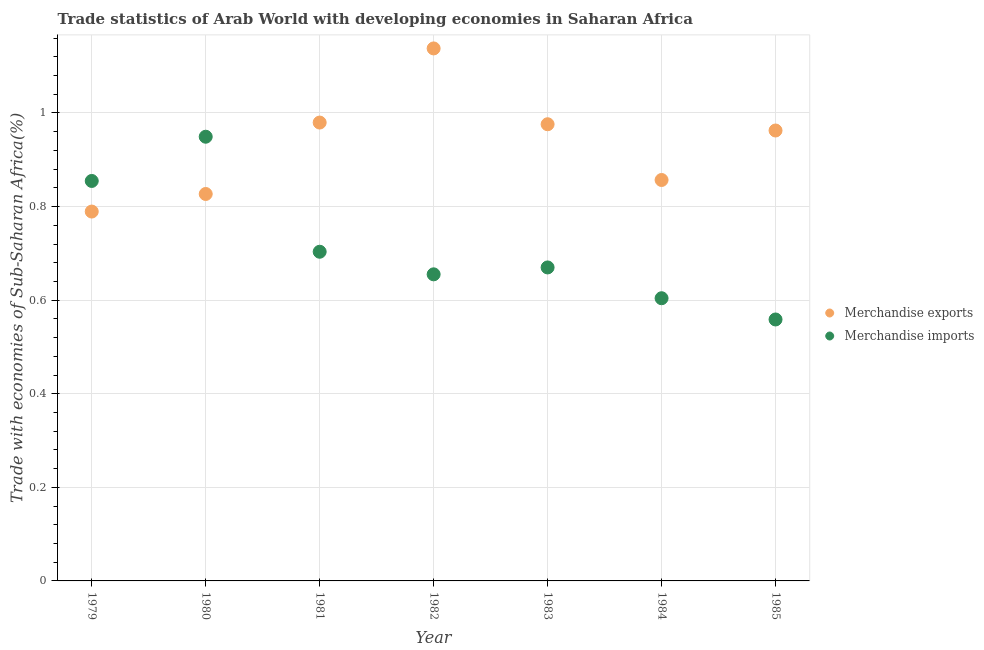How many different coloured dotlines are there?
Provide a succinct answer. 2. Is the number of dotlines equal to the number of legend labels?
Your response must be concise. Yes. What is the merchandise exports in 1981?
Keep it short and to the point. 0.98. Across all years, what is the maximum merchandise exports?
Your answer should be compact. 1.14. Across all years, what is the minimum merchandise exports?
Offer a very short reply. 0.79. In which year was the merchandise exports minimum?
Ensure brevity in your answer.  1979. What is the total merchandise imports in the graph?
Make the answer very short. 5. What is the difference between the merchandise imports in 1980 and that in 1984?
Offer a terse response. 0.35. What is the difference between the merchandise exports in 1985 and the merchandise imports in 1980?
Your answer should be compact. 0.01. What is the average merchandise imports per year?
Your answer should be very brief. 0.71. In the year 1984, what is the difference between the merchandise imports and merchandise exports?
Give a very brief answer. -0.25. In how many years, is the merchandise imports greater than 0.36 %?
Your response must be concise. 7. What is the ratio of the merchandise exports in 1982 to that in 1985?
Keep it short and to the point. 1.18. Is the merchandise imports in 1984 less than that in 1985?
Give a very brief answer. No. What is the difference between the highest and the second highest merchandise imports?
Your response must be concise. 0.09. What is the difference between the highest and the lowest merchandise exports?
Make the answer very short. 0.35. Is the merchandise exports strictly greater than the merchandise imports over the years?
Provide a short and direct response. No. How many years are there in the graph?
Give a very brief answer. 7. Does the graph contain any zero values?
Provide a short and direct response. No. Does the graph contain grids?
Your response must be concise. Yes. Where does the legend appear in the graph?
Keep it short and to the point. Center right. How many legend labels are there?
Provide a short and direct response. 2. What is the title of the graph?
Provide a succinct answer. Trade statistics of Arab World with developing economies in Saharan Africa. What is the label or title of the Y-axis?
Your response must be concise. Trade with economies of Sub-Saharan Africa(%). What is the Trade with economies of Sub-Saharan Africa(%) of Merchandise exports in 1979?
Your response must be concise. 0.79. What is the Trade with economies of Sub-Saharan Africa(%) of Merchandise imports in 1979?
Your response must be concise. 0.85. What is the Trade with economies of Sub-Saharan Africa(%) of Merchandise exports in 1980?
Offer a terse response. 0.83. What is the Trade with economies of Sub-Saharan Africa(%) of Merchandise imports in 1980?
Provide a short and direct response. 0.95. What is the Trade with economies of Sub-Saharan Africa(%) of Merchandise exports in 1981?
Your answer should be compact. 0.98. What is the Trade with economies of Sub-Saharan Africa(%) in Merchandise imports in 1981?
Keep it short and to the point. 0.7. What is the Trade with economies of Sub-Saharan Africa(%) of Merchandise exports in 1982?
Keep it short and to the point. 1.14. What is the Trade with economies of Sub-Saharan Africa(%) of Merchandise imports in 1982?
Provide a short and direct response. 0.66. What is the Trade with economies of Sub-Saharan Africa(%) in Merchandise exports in 1983?
Keep it short and to the point. 0.98. What is the Trade with economies of Sub-Saharan Africa(%) of Merchandise imports in 1983?
Your answer should be very brief. 0.67. What is the Trade with economies of Sub-Saharan Africa(%) in Merchandise exports in 1984?
Offer a very short reply. 0.86. What is the Trade with economies of Sub-Saharan Africa(%) in Merchandise imports in 1984?
Offer a terse response. 0.6. What is the Trade with economies of Sub-Saharan Africa(%) of Merchandise exports in 1985?
Provide a succinct answer. 0.96. What is the Trade with economies of Sub-Saharan Africa(%) of Merchandise imports in 1985?
Provide a succinct answer. 0.56. Across all years, what is the maximum Trade with economies of Sub-Saharan Africa(%) of Merchandise exports?
Your response must be concise. 1.14. Across all years, what is the maximum Trade with economies of Sub-Saharan Africa(%) of Merchandise imports?
Provide a short and direct response. 0.95. Across all years, what is the minimum Trade with economies of Sub-Saharan Africa(%) of Merchandise exports?
Your answer should be compact. 0.79. Across all years, what is the minimum Trade with economies of Sub-Saharan Africa(%) of Merchandise imports?
Give a very brief answer. 0.56. What is the total Trade with economies of Sub-Saharan Africa(%) in Merchandise exports in the graph?
Ensure brevity in your answer.  6.53. What is the total Trade with economies of Sub-Saharan Africa(%) in Merchandise imports in the graph?
Make the answer very short. 5. What is the difference between the Trade with economies of Sub-Saharan Africa(%) of Merchandise exports in 1979 and that in 1980?
Make the answer very short. -0.04. What is the difference between the Trade with economies of Sub-Saharan Africa(%) in Merchandise imports in 1979 and that in 1980?
Offer a very short reply. -0.09. What is the difference between the Trade with economies of Sub-Saharan Africa(%) of Merchandise exports in 1979 and that in 1981?
Offer a very short reply. -0.19. What is the difference between the Trade with economies of Sub-Saharan Africa(%) in Merchandise imports in 1979 and that in 1981?
Ensure brevity in your answer.  0.15. What is the difference between the Trade with economies of Sub-Saharan Africa(%) of Merchandise exports in 1979 and that in 1982?
Your response must be concise. -0.35. What is the difference between the Trade with economies of Sub-Saharan Africa(%) in Merchandise imports in 1979 and that in 1982?
Provide a short and direct response. 0.2. What is the difference between the Trade with economies of Sub-Saharan Africa(%) of Merchandise exports in 1979 and that in 1983?
Make the answer very short. -0.19. What is the difference between the Trade with economies of Sub-Saharan Africa(%) in Merchandise imports in 1979 and that in 1983?
Ensure brevity in your answer.  0.18. What is the difference between the Trade with economies of Sub-Saharan Africa(%) in Merchandise exports in 1979 and that in 1984?
Offer a very short reply. -0.07. What is the difference between the Trade with economies of Sub-Saharan Africa(%) in Merchandise imports in 1979 and that in 1984?
Offer a very short reply. 0.25. What is the difference between the Trade with economies of Sub-Saharan Africa(%) of Merchandise exports in 1979 and that in 1985?
Offer a terse response. -0.17. What is the difference between the Trade with economies of Sub-Saharan Africa(%) in Merchandise imports in 1979 and that in 1985?
Your response must be concise. 0.3. What is the difference between the Trade with economies of Sub-Saharan Africa(%) in Merchandise exports in 1980 and that in 1981?
Give a very brief answer. -0.15. What is the difference between the Trade with economies of Sub-Saharan Africa(%) in Merchandise imports in 1980 and that in 1981?
Offer a very short reply. 0.25. What is the difference between the Trade with economies of Sub-Saharan Africa(%) in Merchandise exports in 1980 and that in 1982?
Make the answer very short. -0.31. What is the difference between the Trade with economies of Sub-Saharan Africa(%) of Merchandise imports in 1980 and that in 1982?
Your response must be concise. 0.29. What is the difference between the Trade with economies of Sub-Saharan Africa(%) of Merchandise exports in 1980 and that in 1983?
Provide a short and direct response. -0.15. What is the difference between the Trade with economies of Sub-Saharan Africa(%) in Merchandise imports in 1980 and that in 1983?
Ensure brevity in your answer.  0.28. What is the difference between the Trade with economies of Sub-Saharan Africa(%) in Merchandise exports in 1980 and that in 1984?
Keep it short and to the point. -0.03. What is the difference between the Trade with economies of Sub-Saharan Africa(%) of Merchandise imports in 1980 and that in 1984?
Give a very brief answer. 0.35. What is the difference between the Trade with economies of Sub-Saharan Africa(%) of Merchandise exports in 1980 and that in 1985?
Keep it short and to the point. -0.14. What is the difference between the Trade with economies of Sub-Saharan Africa(%) of Merchandise imports in 1980 and that in 1985?
Your answer should be very brief. 0.39. What is the difference between the Trade with economies of Sub-Saharan Africa(%) in Merchandise exports in 1981 and that in 1982?
Provide a short and direct response. -0.16. What is the difference between the Trade with economies of Sub-Saharan Africa(%) in Merchandise imports in 1981 and that in 1982?
Give a very brief answer. 0.05. What is the difference between the Trade with economies of Sub-Saharan Africa(%) in Merchandise exports in 1981 and that in 1983?
Provide a succinct answer. 0. What is the difference between the Trade with economies of Sub-Saharan Africa(%) of Merchandise imports in 1981 and that in 1983?
Your response must be concise. 0.03. What is the difference between the Trade with economies of Sub-Saharan Africa(%) in Merchandise exports in 1981 and that in 1984?
Give a very brief answer. 0.12. What is the difference between the Trade with economies of Sub-Saharan Africa(%) in Merchandise imports in 1981 and that in 1984?
Offer a terse response. 0.1. What is the difference between the Trade with economies of Sub-Saharan Africa(%) of Merchandise exports in 1981 and that in 1985?
Your answer should be compact. 0.02. What is the difference between the Trade with economies of Sub-Saharan Africa(%) in Merchandise imports in 1981 and that in 1985?
Give a very brief answer. 0.14. What is the difference between the Trade with economies of Sub-Saharan Africa(%) in Merchandise exports in 1982 and that in 1983?
Keep it short and to the point. 0.16. What is the difference between the Trade with economies of Sub-Saharan Africa(%) in Merchandise imports in 1982 and that in 1983?
Offer a terse response. -0.01. What is the difference between the Trade with economies of Sub-Saharan Africa(%) of Merchandise exports in 1982 and that in 1984?
Keep it short and to the point. 0.28. What is the difference between the Trade with economies of Sub-Saharan Africa(%) of Merchandise imports in 1982 and that in 1984?
Offer a very short reply. 0.05. What is the difference between the Trade with economies of Sub-Saharan Africa(%) in Merchandise exports in 1982 and that in 1985?
Your answer should be very brief. 0.18. What is the difference between the Trade with economies of Sub-Saharan Africa(%) of Merchandise imports in 1982 and that in 1985?
Give a very brief answer. 0.1. What is the difference between the Trade with economies of Sub-Saharan Africa(%) in Merchandise exports in 1983 and that in 1984?
Provide a short and direct response. 0.12. What is the difference between the Trade with economies of Sub-Saharan Africa(%) in Merchandise imports in 1983 and that in 1984?
Your response must be concise. 0.07. What is the difference between the Trade with economies of Sub-Saharan Africa(%) in Merchandise exports in 1983 and that in 1985?
Give a very brief answer. 0.01. What is the difference between the Trade with economies of Sub-Saharan Africa(%) of Merchandise imports in 1983 and that in 1985?
Keep it short and to the point. 0.11. What is the difference between the Trade with economies of Sub-Saharan Africa(%) in Merchandise exports in 1984 and that in 1985?
Offer a terse response. -0.11. What is the difference between the Trade with economies of Sub-Saharan Africa(%) of Merchandise imports in 1984 and that in 1985?
Your answer should be very brief. 0.05. What is the difference between the Trade with economies of Sub-Saharan Africa(%) of Merchandise exports in 1979 and the Trade with economies of Sub-Saharan Africa(%) of Merchandise imports in 1980?
Offer a very short reply. -0.16. What is the difference between the Trade with economies of Sub-Saharan Africa(%) in Merchandise exports in 1979 and the Trade with economies of Sub-Saharan Africa(%) in Merchandise imports in 1981?
Offer a terse response. 0.09. What is the difference between the Trade with economies of Sub-Saharan Africa(%) of Merchandise exports in 1979 and the Trade with economies of Sub-Saharan Africa(%) of Merchandise imports in 1982?
Your response must be concise. 0.13. What is the difference between the Trade with economies of Sub-Saharan Africa(%) of Merchandise exports in 1979 and the Trade with economies of Sub-Saharan Africa(%) of Merchandise imports in 1983?
Provide a succinct answer. 0.12. What is the difference between the Trade with economies of Sub-Saharan Africa(%) of Merchandise exports in 1979 and the Trade with economies of Sub-Saharan Africa(%) of Merchandise imports in 1984?
Ensure brevity in your answer.  0.19. What is the difference between the Trade with economies of Sub-Saharan Africa(%) in Merchandise exports in 1979 and the Trade with economies of Sub-Saharan Africa(%) in Merchandise imports in 1985?
Your answer should be very brief. 0.23. What is the difference between the Trade with economies of Sub-Saharan Africa(%) of Merchandise exports in 1980 and the Trade with economies of Sub-Saharan Africa(%) of Merchandise imports in 1981?
Your answer should be compact. 0.12. What is the difference between the Trade with economies of Sub-Saharan Africa(%) of Merchandise exports in 1980 and the Trade with economies of Sub-Saharan Africa(%) of Merchandise imports in 1982?
Your response must be concise. 0.17. What is the difference between the Trade with economies of Sub-Saharan Africa(%) in Merchandise exports in 1980 and the Trade with economies of Sub-Saharan Africa(%) in Merchandise imports in 1983?
Make the answer very short. 0.16. What is the difference between the Trade with economies of Sub-Saharan Africa(%) of Merchandise exports in 1980 and the Trade with economies of Sub-Saharan Africa(%) of Merchandise imports in 1984?
Ensure brevity in your answer.  0.22. What is the difference between the Trade with economies of Sub-Saharan Africa(%) in Merchandise exports in 1980 and the Trade with economies of Sub-Saharan Africa(%) in Merchandise imports in 1985?
Your answer should be compact. 0.27. What is the difference between the Trade with economies of Sub-Saharan Africa(%) in Merchandise exports in 1981 and the Trade with economies of Sub-Saharan Africa(%) in Merchandise imports in 1982?
Offer a terse response. 0.32. What is the difference between the Trade with economies of Sub-Saharan Africa(%) in Merchandise exports in 1981 and the Trade with economies of Sub-Saharan Africa(%) in Merchandise imports in 1983?
Provide a short and direct response. 0.31. What is the difference between the Trade with economies of Sub-Saharan Africa(%) in Merchandise exports in 1981 and the Trade with economies of Sub-Saharan Africa(%) in Merchandise imports in 1984?
Your response must be concise. 0.38. What is the difference between the Trade with economies of Sub-Saharan Africa(%) of Merchandise exports in 1981 and the Trade with economies of Sub-Saharan Africa(%) of Merchandise imports in 1985?
Keep it short and to the point. 0.42. What is the difference between the Trade with economies of Sub-Saharan Africa(%) of Merchandise exports in 1982 and the Trade with economies of Sub-Saharan Africa(%) of Merchandise imports in 1983?
Give a very brief answer. 0.47. What is the difference between the Trade with economies of Sub-Saharan Africa(%) in Merchandise exports in 1982 and the Trade with economies of Sub-Saharan Africa(%) in Merchandise imports in 1984?
Ensure brevity in your answer.  0.53. What is the difference between the Trade with economies of Sub-Saharan Africa(%) in Merchandise exports in 1982 and the Trade with economies of Sub-Saharan Africa(%) in Merchandise imports in 1985?
Your answer should be very brief. 0.58. What is the difference between the Trade with economies of Sub-Saharan Africa(%) in Merchandise exports in 1983 and the Trade with economies of Sub-Saharan Africa(%) in Merchandise imports in 1984?
Keep it short and to the point. 0.37. What is the difference between the Trade with economies of Sub-Saharan Africa(%) in Merchandise exports in 1983 and the Trade with economies of Sub-Saharan Africa(%) in Merchandise imports in 1985?
Your answer should be compact. 0.42. What is the difference between the Trade with economies of Sub-Saharan Africa(%) in Merchandise exports in 1984 and the Trade with economies of Sub-Saharan Africa(%) in Merchandise imports in 1985?
Your response must be concise. 0.3. What is the average Trade with economies of Sub-Saharan Africa(%) in Merchandise exports per year?
Your response must be concise. 0.93. What is the average Trade with economies of Sub-Saharan Africa(%) of Merchandise imports per year?
Your answer should be very brief. 0.71. In the year 1979, what is the difference between the Trade with economies of Sub-Saharan Africa(%) in Merchandise exports and Trade with economies of Sub-Saharan Africa(%) in Merchandise imports?
Offer a very short reply. -0.07. In the year 1980, what is the difference between the Trade with economies of Sub-Saharan Africa(%) in Merchandise exports and Trade with economies of Sub-Saharan Africa(%) in Merchandise imports?
Make the answer very short. -0.12. In the year 1981, what is the difference between the Trade with economies of Sub-Saharan Africa(%) in Merchandise exports and Trade with economies of Sub-Saharan Africa(%) in Merchandise imports?
Give a very brief answer. 0.28. In the year 1982, what is the difference between the Trade with economies of Sub-Saharan Africa(%) in Merchandise exports and Trade with economies of Sub-Saharan Africa(%) in Merchandise imports?
Provide a short and direct response. 0.48. In the year 1983, what is the difference between the Trade with economies of Sub-Saharan Africa(%) of Merchandise exports and Trade with economies of Sub-Saharan Africa(%) of Merchandise imports?
Offer a terse response. 0.31. In the year 1984, what is the difference between the Trade with economies of Sub-Saharan Africa(%) in Merchandise exports and Trade with economies of Sub-Saharan Africa(%) in Merchandise imports?
Your answer should be compact. 0.25. In the year 1985, what is the difference between the Trade with economies of Sub-Saharan Africa(%) of Merchandise exports and Trade with economies of Sub-Saharan Africa(%) of Merchandise imports?
Make the answer very short. 0.4. What is the ratio of the Trade with economies of Sub-Saharan Africa(%) in Merchandise exports in 1979 to that in 1980?
Your answer should be very brief. 0.95. What is the ratio of the Trade with economies of Sub-Saharan Africa(%) in Merchandise imports in 1979 to that in 1980?
Your answer should be compact. 0.9. What is the ratio of the Trade with economies of Sub-Saharan Africa(%) in Merchandise exports in 1979 to that in 1981?
Offer a terse response. 0.81. What is the ratio of the Trade with economies of Sub-Saharan Africa(%) of Merchandise imports in 1979 to that in 1981?
Your answer should be compact. 1.22. What is the ratio of the Trade with economies of Sub-Saharan Africa(%) in Merchandise exports in 1979 to that in 1982?
Keep it short and to the point. 0.69. What is the ratio of the Trade with economies of Sub-Saharan Africa(%) of Merchandise imports in 1979 to that in 1982?
Offer a terse response. 1.3. What is the ratio of the Trade with economies of Sub-Saharan Africa(%) in Merchandise exports in 1979 to that in 1983?
Ensure brevity in your answer.  0.81. What is the ratio of the Trade with economies of Sub-Saharan Africa(%) of Merchandise imports in 1979 to that in 1983?
Make the answer very short. 1.28. What is the ratio of the Trade with economies of Sub-Saharan Africa(%) of Merchandise exports in 1979 to that in 1984?
Your answer should be very brief. 0.92. What is the ratio of the Trade with economies of Sub-Saharan Africa(%) of Merchandise imports in 1979 to that in 1984?
Ensure brevity in your answer.  1.41. What is the ratio of the Trade with economies of Sub-Saharan Africa(%) in Merchandise exports in 1979 to that in 1985?
Give a very brief answer. 0.82. What is the ratio of the Trade with economies of Sub-Saharan Africa(%) in Merchandise imports in 1979 to that in 1985?
Provide a short and direct response. 1.53. What is the ratio of the Trade with economies of Sub-Saharan Africa(%) of Merchandise exports in 1980 to that in 1981?
Your response must be concise. 0.84. What is the ratio of the Trade with economies of Sub-Saharan Africa(%) of Merchandise imports in 1980 to that in 1981?
Offer a terse response. 1.35. What is the ratio of the Trade with economies of Sub-Saharan Africa(%) of Merchandise exports in 1980 to that in 1982?
Provide a short and direct response. 0.73. What is the ratio of the Trade with economies of Sub-Saharan Africa(%) in Merchandise imports in 1980 to that in 1982?
Ensure brevity in your answer.  1.45. What is the ratio of the Trade with economies of Sub-Saharan Africa(%) of Merchandise exports in 1980 to that in 1983?
Provide a short and direct response. 0.85. What is the ratio of the Trade with economies of Sub-Saharan Africa(%) in Merchandise imports in 1980 to that in 1983?
Your answer should be very brief. 1.42. What is the ratio of the Trade with economies of Sub-Saharan Africa(%) of Merchandise exports in 1980 to that in 1984?
Make the answer very short. 0.97. What is the ratio of the Trade with economies of Sub-Saharan Africa(%) of Merchandise imports in 1980 to that in 1984?
Offer a very short reply. 1.57. What is the ratio of the Trade with economies of Sub-Saharan Africa(%) in Merchandise exports in 1980 to that in 1985?
Your answer should be very brief. 0.86. What is the ratio of the Trade with economies of Sub-Saharan Africa(%) of Merchandise imports in 1980 to that in 1985?
Offer a very short reply. 1.7. What is the ratio of the Trade with economies of Sub-Saharan Africa(%) of Merchandise exports in 1981 to that in 1982?
Offer a terse response. 0.86. What is the ratio of the Trade with economies of Sub-Saharan Africa(%) in Merchandise imports in 1981 to that in 1982?
Keep it short and to the point. 1.07. What is the ratio of the Trade with economies of Sub-Saharan Africa(%) of Merchandise exports in 1981 to that in 1983?
Ensure brevity in your answer.  1. What is the ratio of the Trade with economies of Sub-Saharan Africa(%) in Merchandise imports in 1981 to that in 1983?
Offer a terse response. 1.05. What is the ratio of the Trade with economies of Sub-Saharan Africa(%) in Merchandise exports in 1981 to that in 1984?
Your answer should be compact. 1.14. What is the ratio of the Trade with economies of Sub-Saharan Africa(%) of Merchandise imports in 1981 to that in 1984?
Offer a terse response. 1.16. What is the ratio of the Trade with economies of Sub-Saharan Africa(%) in Merchandise exports in 1981 to that in 1985?
Your response must be concise. 1.02. What is the ratio of the Trade with economies of Sub-Saharan Africa(%) in Merchandise imports in 1981 to that in 1985?
Offer a very short reply. 1.26. What is the ratio of the Trade with economies of Sub-Saharan Africa(%) in Merchandise exports in 1982 to that in 1983?
Ensure brevity in your answer.  1.17. What is the ratio of the Trade with economies of Sub-Saharan Africa(%) in Merchandise imports in 1982 to that in 1983?
Make the answer very short. 0.98. What is the ratio of the Trade with economies of Sub-Saharan Africa(%) in Merchandise exports in 1982 to that in 1984?
Your response must be concise. 1.33. What is the ratio of the Trade with economies of Sub-Saharan Africa(%) of Merchandise imports in 1982 to that in 1984?
Provide a short and direct response. 1.08. What is the ratio of the Trade with economies of Sub-Saharan Africa(%) of Merchandise exports in 1982 to that in 1985?
Provide a succinct answer. 1.18. What is the ratio of the Trade with economies of Sub-Saharan Africa(%) in Merchandise imports in 1982 to that in 1985?
Offer a terse response. 1.17. What is the ratio of the Trade with economies of Sub-Saharan Africa(%) of Merchandise exports in 1983 to that in 1984?
Ensure brevity in your answer.  1.14. What is the ratio of the Trade with economies of Sub-Saharan Africa(%) in Merchandise imports in 1983 to that in 1984?
Make the answer very short. 1.11. What is the ratio of the Trade with economies of Sub-Saharan Africa(%) of Merchandise exports in 1983 to that in 1985?
Ensure brevity in your answer.  1.01. What is the ratio of the Trade with economies of Sub-Saharan Africa(%) of Merchandise imports in 1983 to that in 1985?
Your response must be concise. 1.2. What is the ratio of the Trade with economies of Sub-Saharan Africa(%) in Merchandise exports in 1984 to that in 1985?
Offer a very short reply. 0.89. What is the ratio of the Trade with economies of Sub-Saharan Africa(%) in Merchandise imports in 1984 to that in 1985?
Ensure brevity in your answer.  1.08. What is the difference between the highest and the second highest Trade with economies of Sub-Saharan Africa(%) of Merchandise exports?
Your response must be concise. 0.16. What is the difference between the highest and the second highest Trade with economies of Sub-Saharan Africa(%) in Merchandise imports?
Your answer should be very brief. 0.09. What is the difference between the highest and the lowest Trade with economies of Sub-Saharan Africa(%) of Merchandise exports?
Keep it short and to the point. 0.35. What is the difference between the highest and the lowest Trade with economies of Sub-Saharan Africa(%) in Merchandise imports?
Offer a very short reply. 0.39. 